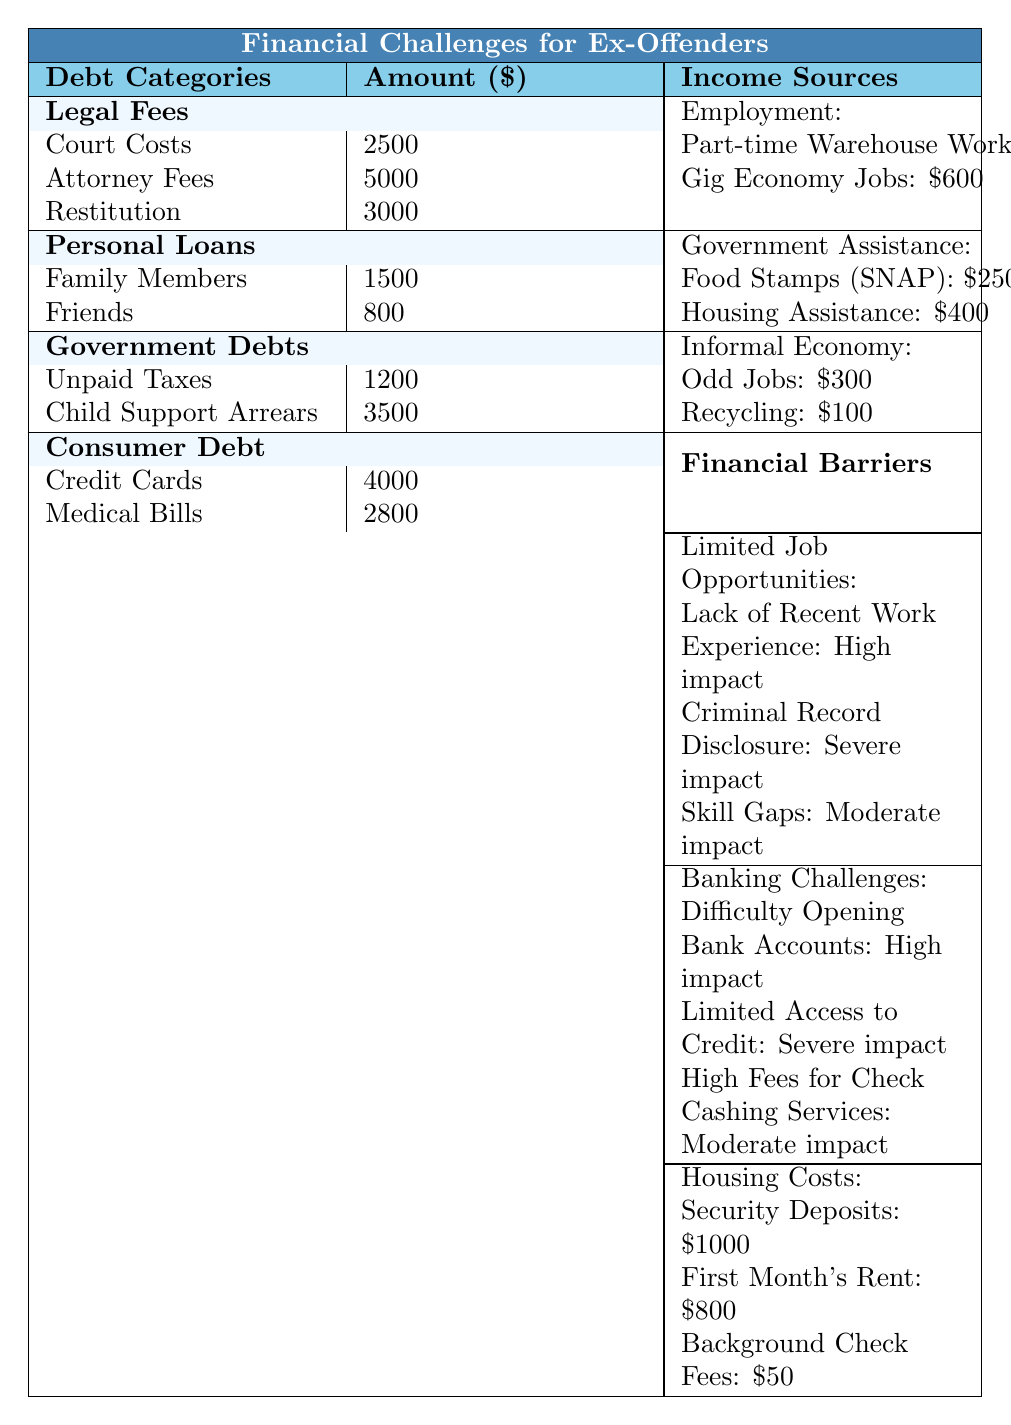What is the total amount of legal fees? By adding the amounts in the Legal Fees category: Court Costs (2500), Attorney Fees (5000), and Restitution (3000), the total is 2500 + 5000 + 3000 = 10500.
Answer: 10500 How many sources of income are listed under Employment? There are two income sources listed under Employment: Part-time Warehouse Work and Gig Economy Jobs.
Answer: 2 What is the highest debt category in terms of total amount? Looking at the amounts across all debt categories, Consumer Debt has the highest individual debts: Credit Cards (4000) and Medical Bills (2800), making its total amount 4000 + 2800 = 6800, which is less than Legal Fees which totals 10500. Therefore, Legal Fees is the highest debt category.
Answer: Legal Fees What is the total amount due for Government Debts? The amounts for Government Debts are Unpaid Taxes (1200) and Child Support Arrears (3500). Adding these gives 1200 + 3500 = 4700.
Answer: 4700 Is the difficulty in opening bank accounts considered a high-impact barrier? Yes, according to the Banking Challenges section of the table, "Difficulty Opening Bank Accounts" is marked as "High impact."
Answer: Yes What is the combined total of Consumer Debt and Government Debts? To find this, add the total amounts from each category: Consumer Debt totals 6800 and Government Debts totals 4700. So, the combined total is 6800 + 4700 = 11500.
Answer: 11500 If an ex-offender works part-time and earns $1200, how much of that income comes from government assistance according to the table? The source of government assistance listed shows that the total income from Food Stamps (SNAP) and Housing Assistance is 250 + 400 = 650.
Answer: 650 What are the total housing costs listed in the table? Housing Costs include Security Deposits (1000), First Month's Rent (800), and Background Check Fees (50). Totaling these amounts gives 1000 + 800 + 50 = 1850.
Answer: 1850 If an ex-offender is facing legal fees and personal loans, what is the total amount owed? Legal Fees total 10500 and Personal Loans total 2300 (1500 and 800). Adding these gives 10500 + 2300 = 12800.
Answer: 12800 To afford the first month’s rent, how much more does an ex-offender need if they only have $700? The cost of the first month's rent is $800. If they have $700, they need 800 - 700 = 100 more.
Answer: 100 